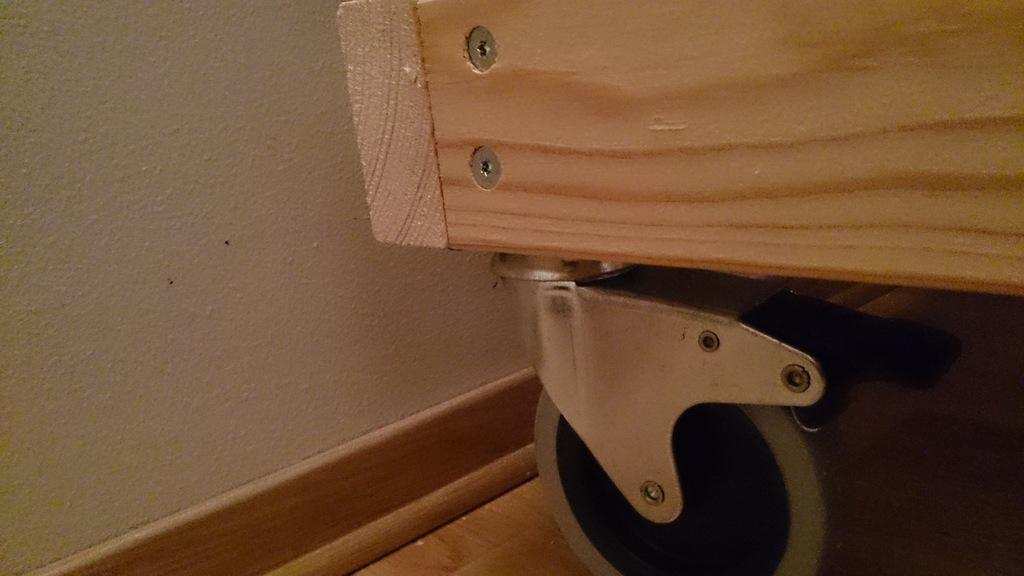What type of structure can be seen in the image? There is a wall in the image. What object is located on the right side of the image? There is a trolley on the right side of the image. What surface is visible in the image? There is a floor visible in the image. What type of lock is present on the wall in the image? There is no lock present on the wall in the image. Can you describe the cemetery visible in the image? There is no cemetery present in the image; it only features a wall, a trolley, and a floor. 